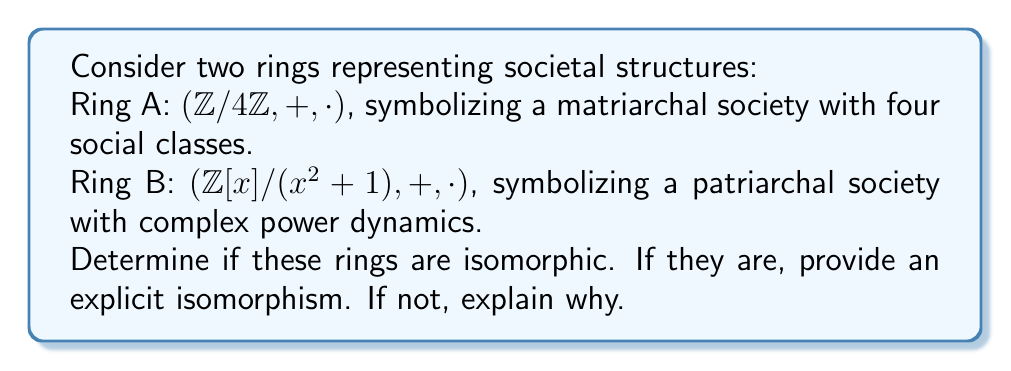What is the answer to this math problem? To determine if the rings are isomorphic, we need to examine their properties and structure:

1. Ring A: $(\mathbb{Z}/4\mathbb{Z}, +, \cdot)$
   - Elements: $\{0, 1, 2, 3\}$
   - Additive structure: Cyclic group of order 4
   - Multiplicative structure: $2^2 = 0$

2. Ring B: $(\mathbb{Z}[x]/(x^2+1), +, \cdot)$
   - Elements: $\{a + bx : a, b \in \mathbb{Z}\}$ where $x^2 = -1$
   - Additive structure: Infinite
   - Multiplicative structure: $(a + bx)(c + dx) = (ac-bd) + (ad+bc)x$

Key observations:
a) Ring A is finite with 4 elements, while Ring B is infinite.
b) Ring A has zero divisors (e.g., $2 \cdot 2 = 0$), while Ring B is an integral domain (no zero divisors).
c) Ring B is isomorphic to the Gaussian integers $\mathbb{Z}[i]$.

These fundamental differences in structure and properties demonstrate that Rings A and B cannot be isomorphic. An isomorphism would preserve the number of elements and the presence or absence of zero divisors.

From an anthropological perspective, this lack of isomorphism could be interpreted as reflecting the fundamental differences between matriarchal and patriarchal societal structures, highlighting how power dynamics and social hierarchies manifest differently in these systems.
Answer: The rings are not isomorphic due to their different cardinalities and algebraic properties. 